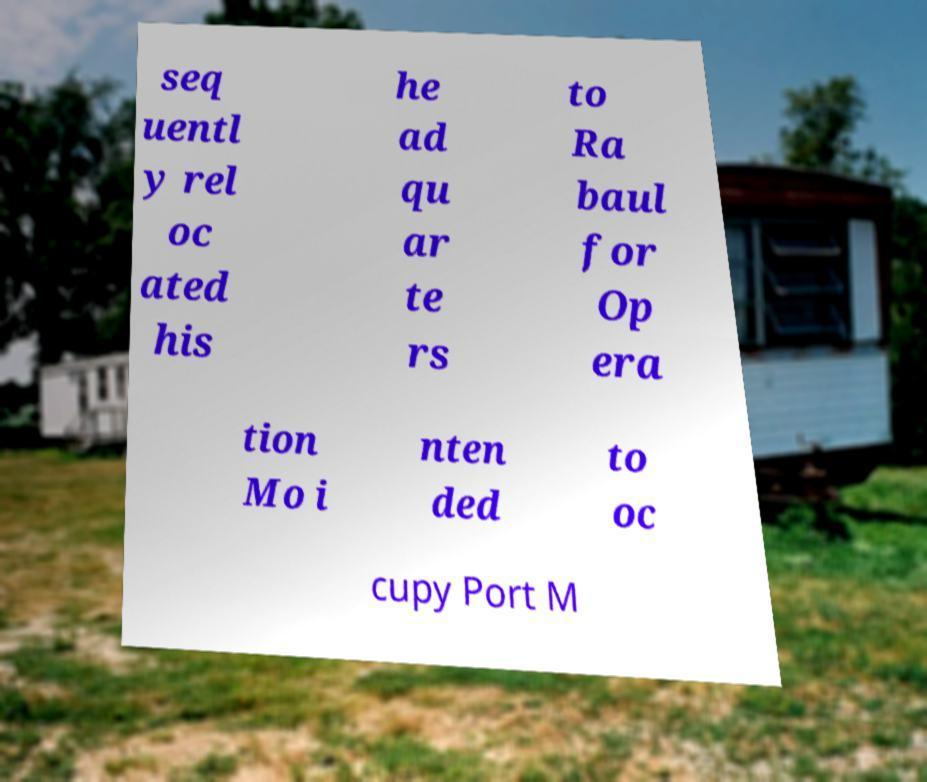Could you assist in decoding the text presented in this image and type it out clearly? seq uentl y rel oc ated his he ad qu ar te rs to Ra baul for Op era tion Mo i nten ded to oc cupy Port M 